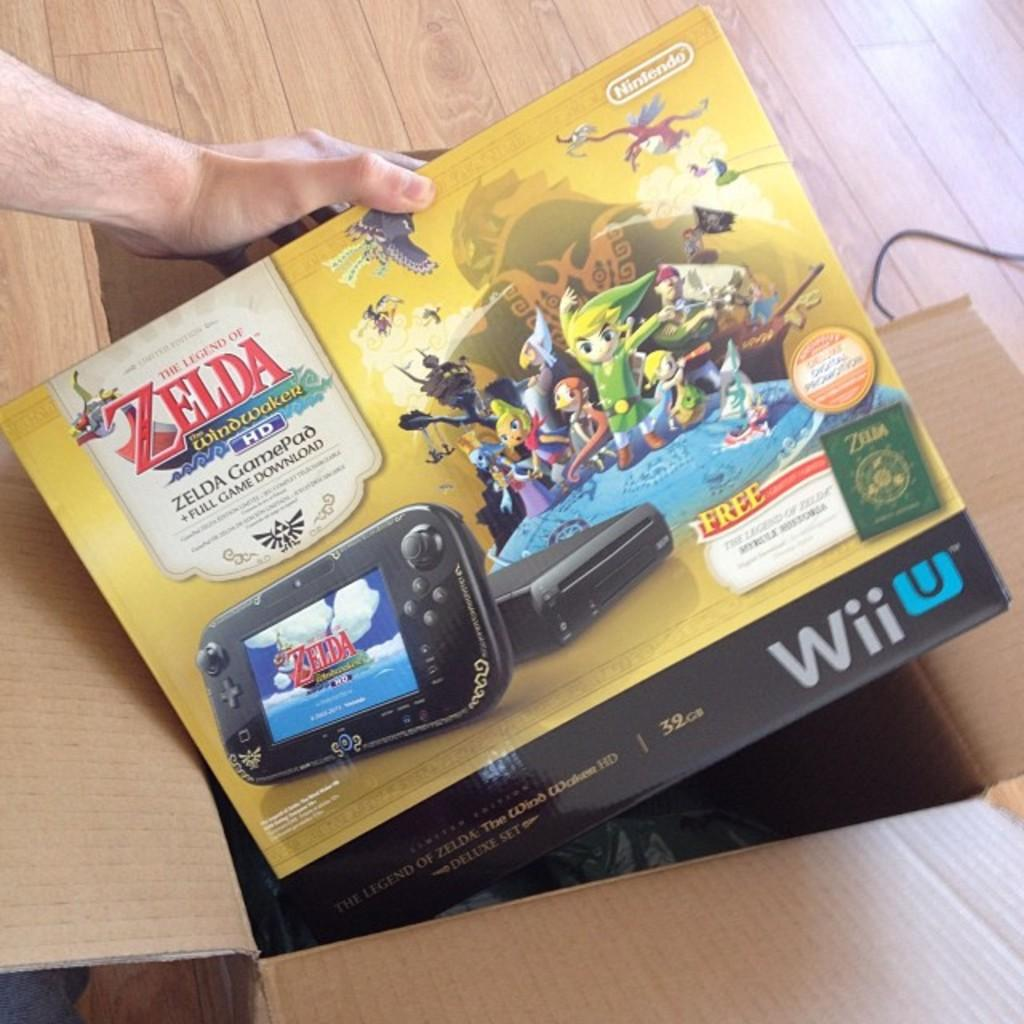<image>
Render a clear and concise summary of the photo. A Wii U that includes the game Zelda Windwaker. 